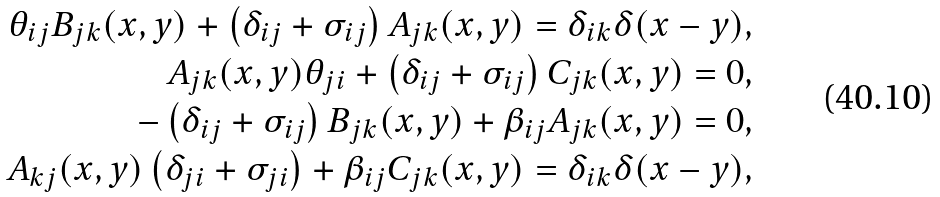Convert formula to latex. <formula><loc_0><loc_0><loc_500><loc_500>\theta _ { i j } B _ { j k } ( x , y ) + \left ( \delta _ { i j } + \sigma _ { i j } \right ) A _ { j k } ( x , y ) = \delta _ { i k } \delta ( x - y ) , \\ A _ { j k } ( x , y ) \theta _ { j i } + \left ( \delta _ { i j } + \sigma _ { i j } \right ) C _ { j k } ( x , y ) = 0 , \\ - \left ( \delta _ { i j } + \sigma _ { i j } \right ) B _ { j k } ( x , y ) + \beta _ { i j } A _ { j k } ( x , y ) = 0 , \\ A _ { k j } ( x , y ) \left ( \delta _ { j i } + \sigma _ { j i } \right ) + \beta _ { i j } C _ { j k } ( x , y ) = \delta _ { i k } \delta ( x - y ) ,</formula> 